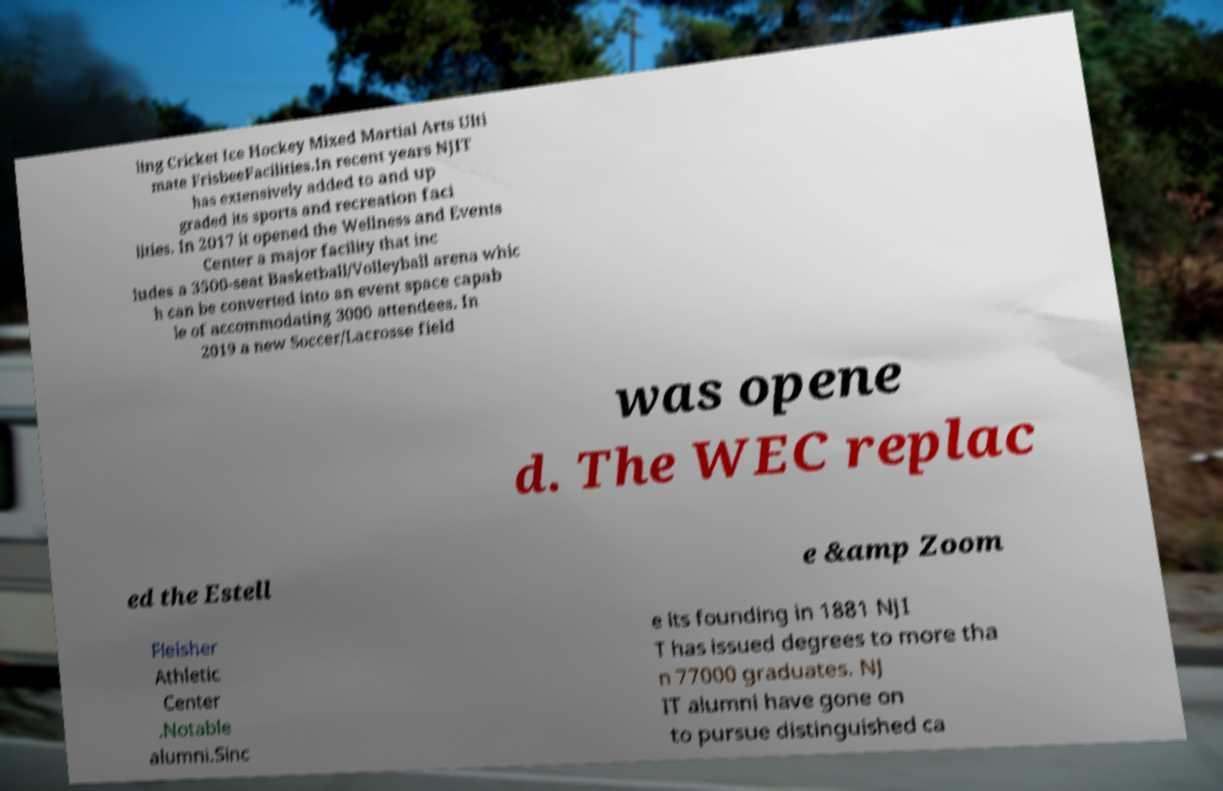Could you assist in decoding the text presented in this image and type it out clearly? ling Cricket Ice Hockey Mixed Martial Arts Ulti mate FrisbeeFacilities.In recent years NJIT has extensively added to and up graded its sports and recreation faci lities. In 2017 it opened the Wellness and Events Center a major facility that inc ludes a 3500-seat Basketball/Volleyball arena whic h can be converted into an event space capab le of accommodating 3000 attendees. In 2019 a new Soccer/Lacrosse field was opene d. The WEC replac ed the Estell e &amp Zoom Fleisher Athletic Center .Notable alumni.Sinc e its founding in 1881 NJI T has issued degrees to more tha n 77000 graduates. NJ IT alumni have gone on to pursue distinguished ca 